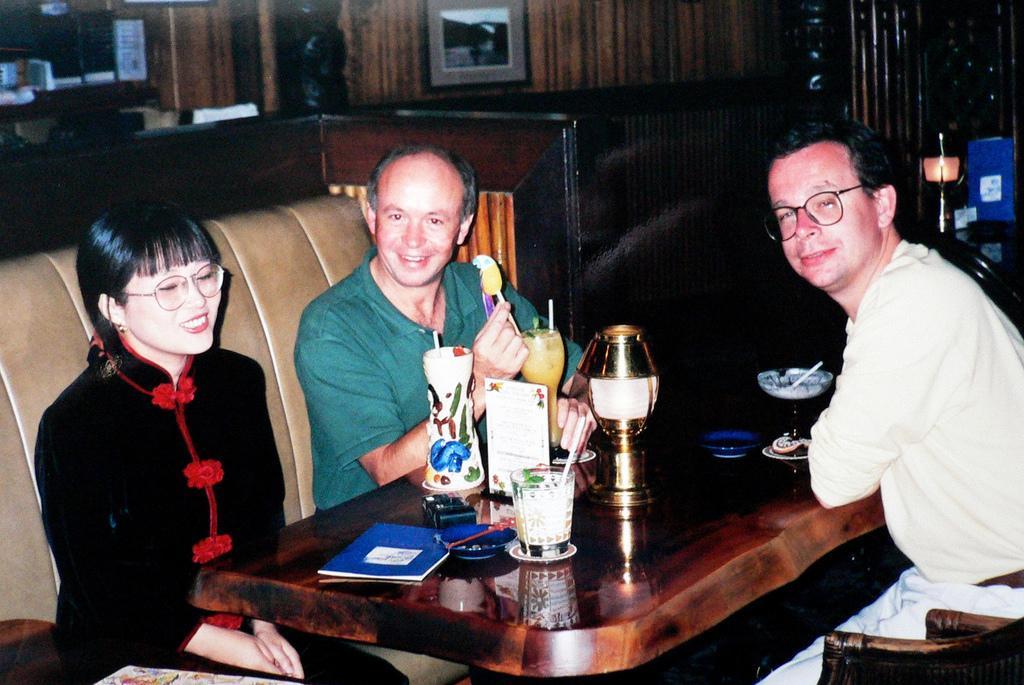Please provide a concise description of this image. This is the picture of three people sitting on the sofas around the table on which there are some things. 